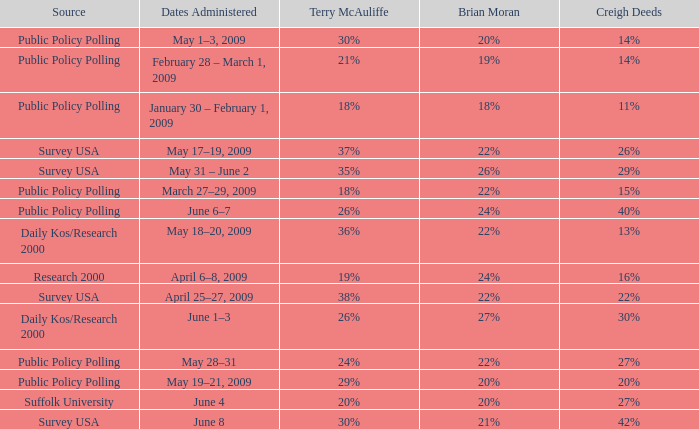Which Terry McAuliffe is it that has a Dates Administered on June 6–7? 26%. 